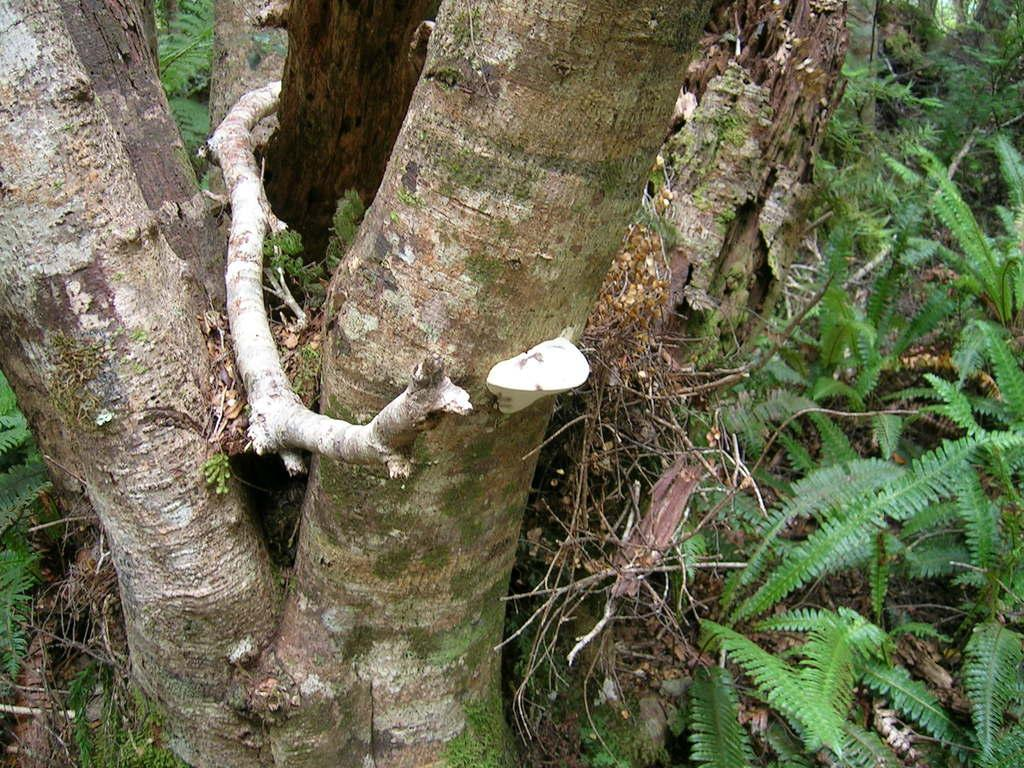What type of plant material can be seen in the image? There are dry leaves, stems, and twigs in the image. What part of a tree is visible in the image? The roots and trunk of a tree are visible in the image. What type of credit card is being used by the army of cows in the image? There are no credit cards, army, or cows present in the image. 